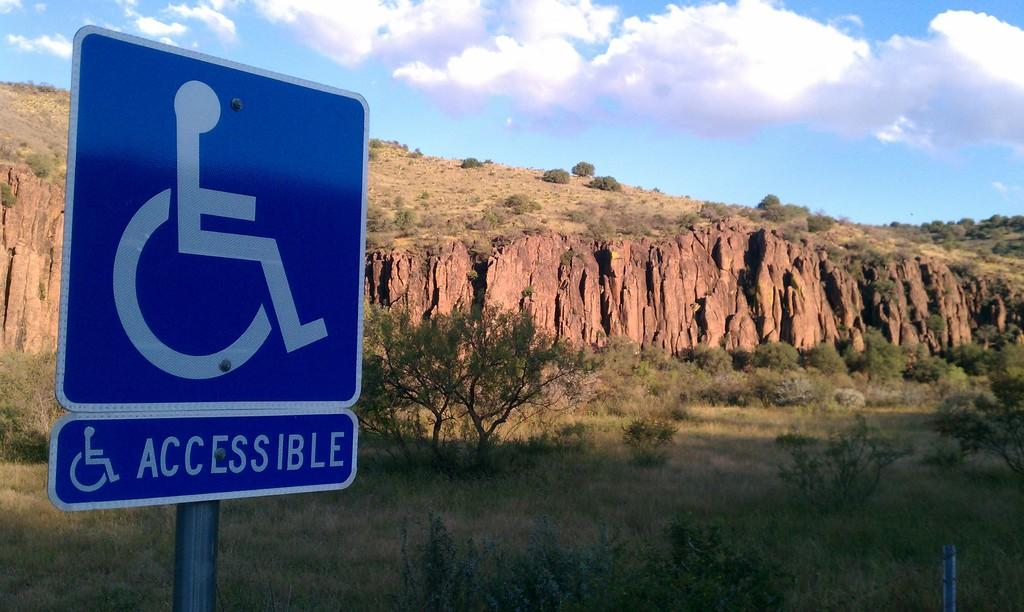<image>
Render a clear and concise summary of the photo. accessible sign on the side of the road with cliffs near by 